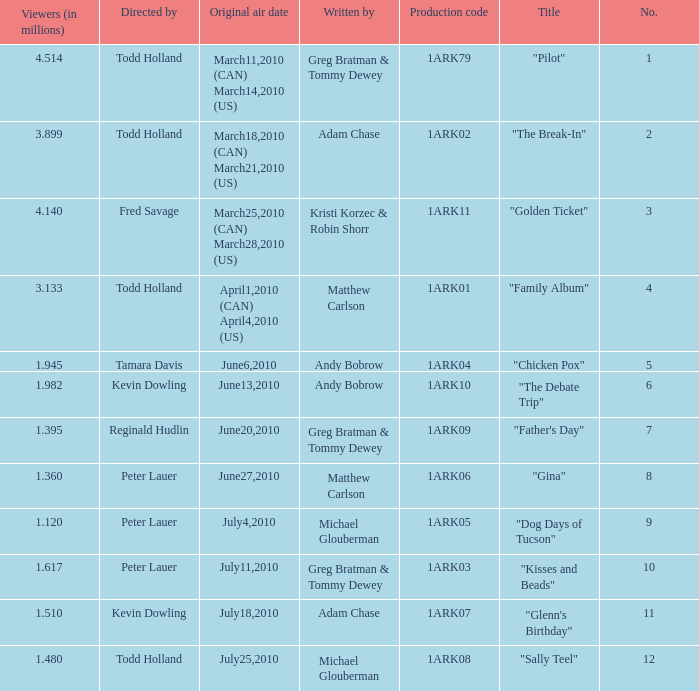List all who wrote for production code 1ark07. Adam Chase. 